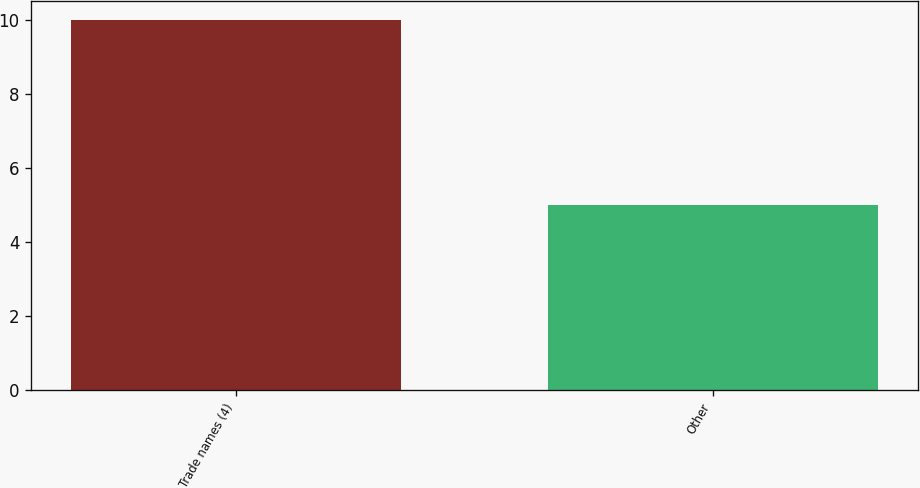<chart> <loc_0><loc_0><loc_500><loc_500><bar_chart><fcel>Trade names (4)<fcel>Other<nl><fcel>10<fcel>5<nl></chart> 